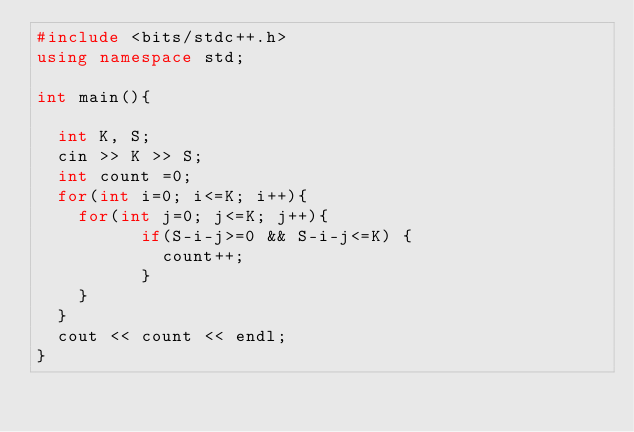<code> <loc_0><loc_0><loc_500><loc_500><_C++_>#include <bits/stdc++.h>
using namespace std;

int main(){
  
  int K, S;
  cin >> K >> S;
  int count =0;
  for(int i=0; i<=K; i++){
  	for(int j=0; j<=K; j++){
          if(S-i-j>=0 && S-i-j<=K) {
            count++;
          }
    }
  }
  cout << count << endl;
}</code> 